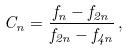Convert formula to latex. <formula><loc_0><loc_0><loc_500><loc_500>C _ { n } = \frac { f _ { n } - f _ { 2 n } } { f _ { 2 n } - f _ { 4 n } } \, ,</formula> 